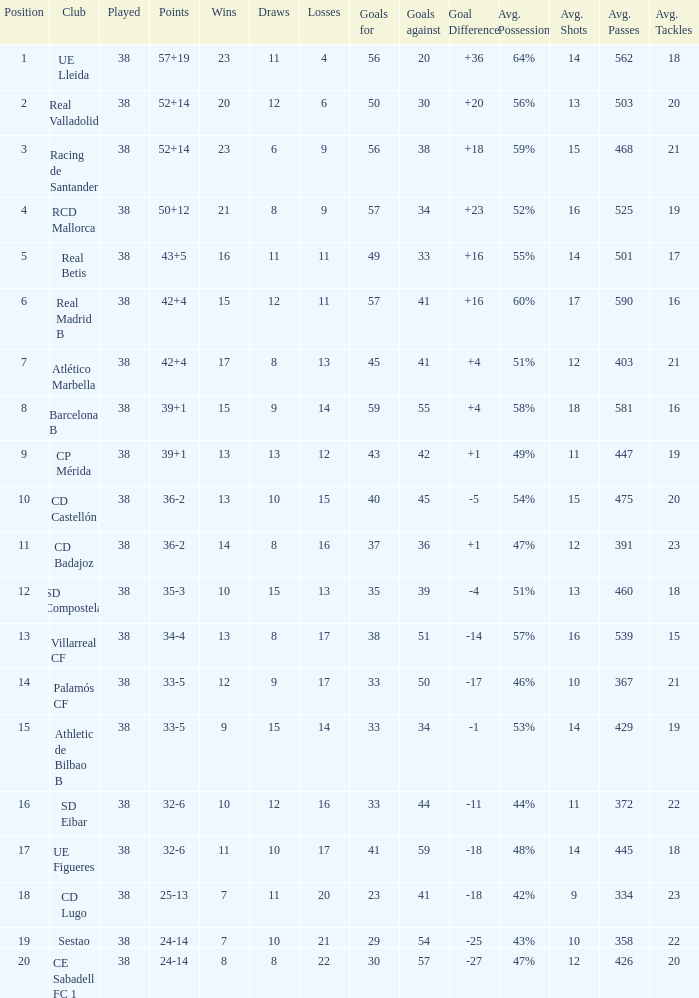What is the highest number played with a goal difference less than -27? None. 